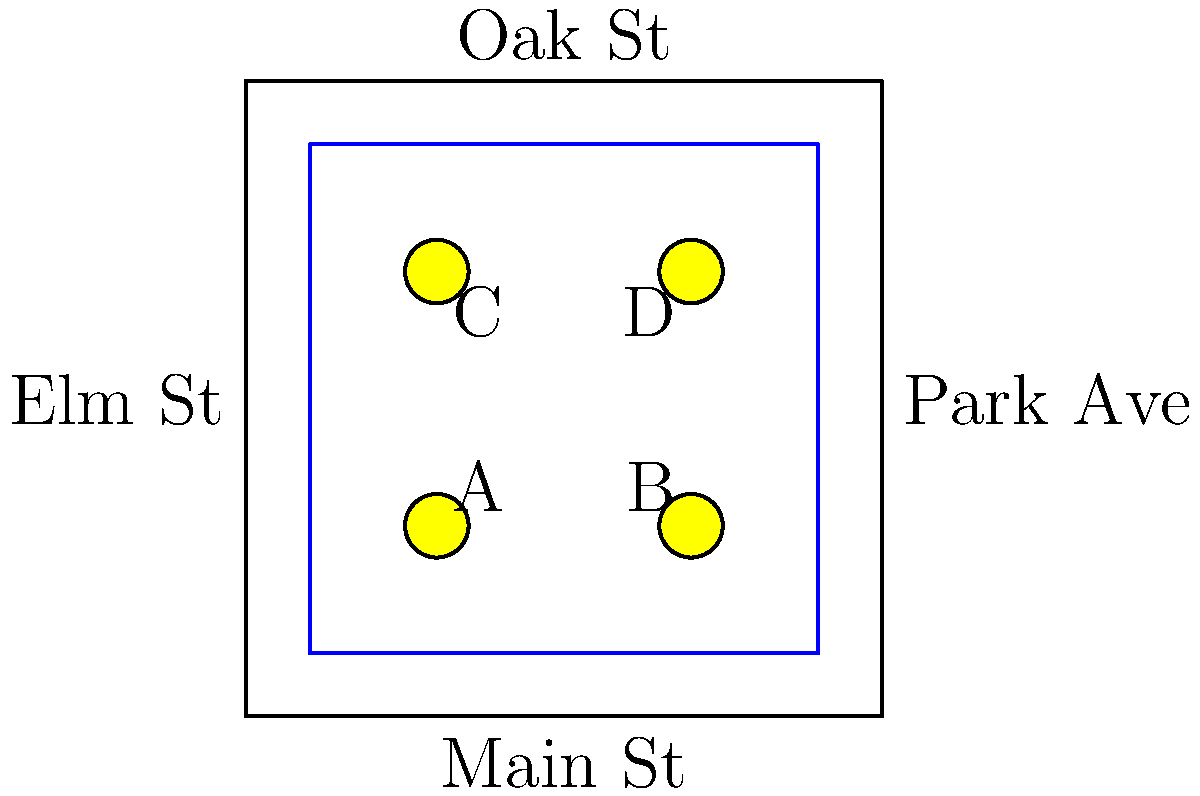Given the street map diagram, calculate the optimal layout for the parade floats to ensure equal spacing along the parade route. If the total length of the parade route is 320 meters, what should be the distance between each float? To solve this problem, we'll follow these steps:

1. Identify the number of floats:
   From the diagram, we can see 4 floats labeled A, B, C, and D.

2. Determine the parade route:
   The blue line forms a square route around the central block.

3. Calculate the number of spaces between floats:
   With 4 floats, there are 5 spaces (including the space from the last float back to the first).

4. Use the formula:
   $\text{Distance between floats} = \frac{\text{Total route length}}{\text{Number of spaces}}$

5. Plug in the values:
   $\text{Distance between floats} = \frac{320 \text{ meters}}{5}$

6. Perform the calculation:
   $\text{Distance between floats} = 64 \text{ meters}$

This layout ensures that the floats are evenly spaced along the parade route, optimizing the viewing experience for spectators and maintaining a consistent flow of the parade.
Answer: 64 meters 